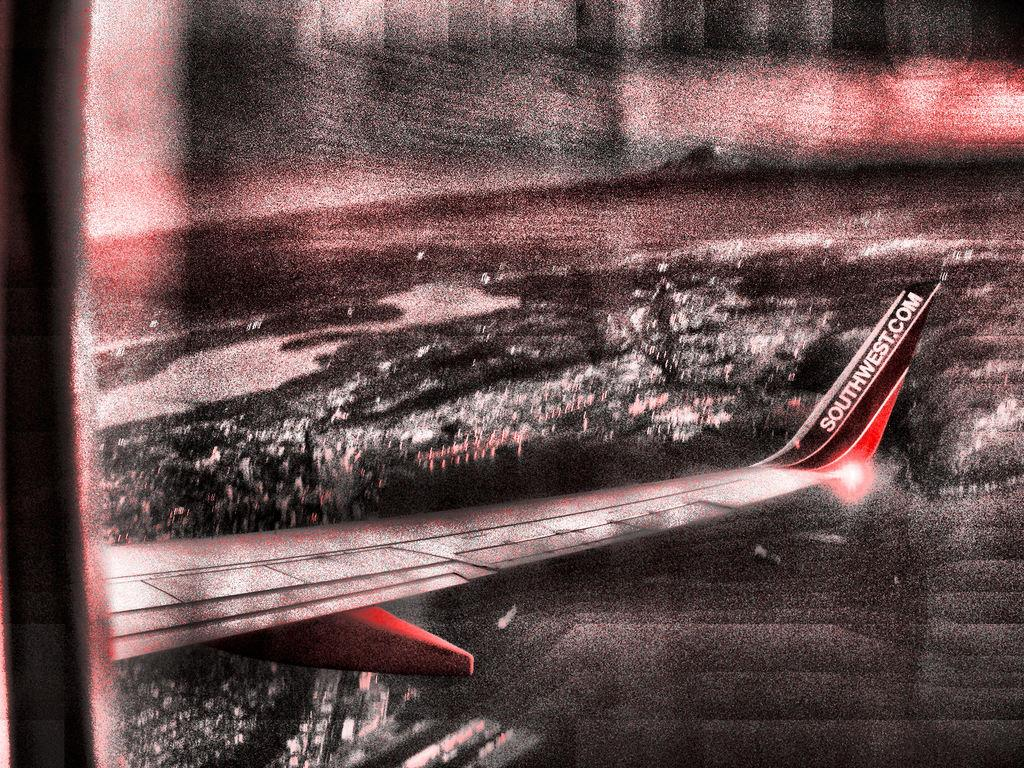<image>
Offer a succinct explanation of the picture presented. The website southwest.com is visible in white lettering. 